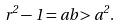<formula> <loc_0><loc_0><loc_500><loc_500>r ^ { 2 } - 1 = a b > a ^ { 2 } .</formula> 